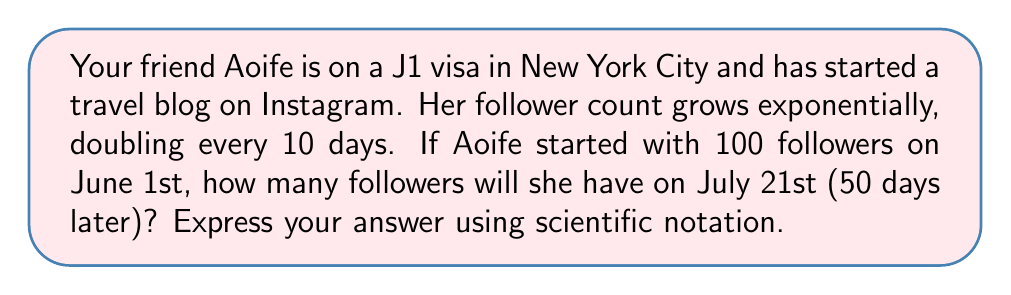Can you answer this question? Let's approach this step-by-step using an exponential function:

1) The general form of an exponential growth function is:

   $$A(t) = A_0 \cdot b^t$$

   Where:
   $A(t)$ is the amount after time $t$
   $A_0$ is the initial amount
   $b$ is the growth factor per unit time
   $t$ is the time elapsed

2) We know:
   $A_0 = 100$ (initial followers)
   The count doubles every 10 days, so $b^{10} = 2$

3) To find $b$:
   $$b^{10} = 2$$
   $$b = 2^{\frac{1}{10}} \approx 1.0718$$

4) Now we can write our function:
   $$A(t) = 100 \cdot (1.0718)^t$$

   Where $t$ is measured in days.

5) We want to know the follower count after 50 days, so let's calculate $A(50)$:

   $$A(50) = 100 \cdot (1.0718)^{50}$$

6) Using a calculator:
   $$A(50) = 100 \cdot 31.5443 = 3154.43$$

7) Rounding to the nearest whole number and expressing in scientific notation:
   $$3.2 \times 10^3$$
Answer: $3.2 \times 10^3$ followers 